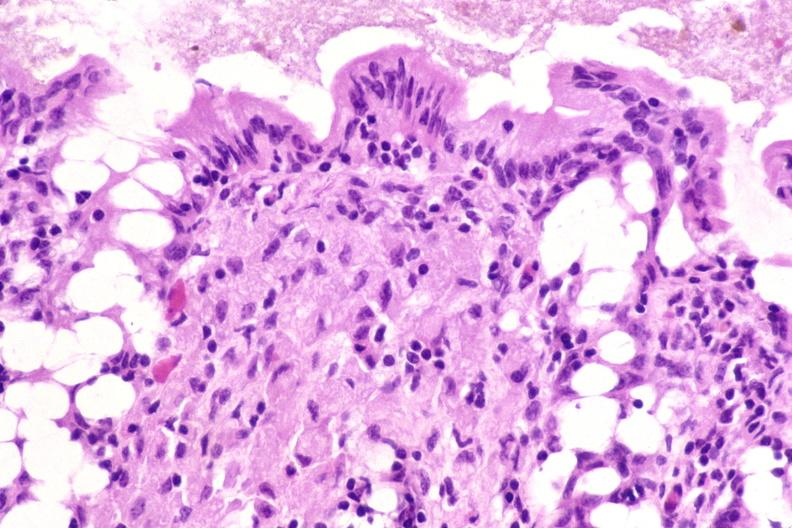s gastrointestinal present?
Answer the question using a single word or phrase. Yes 